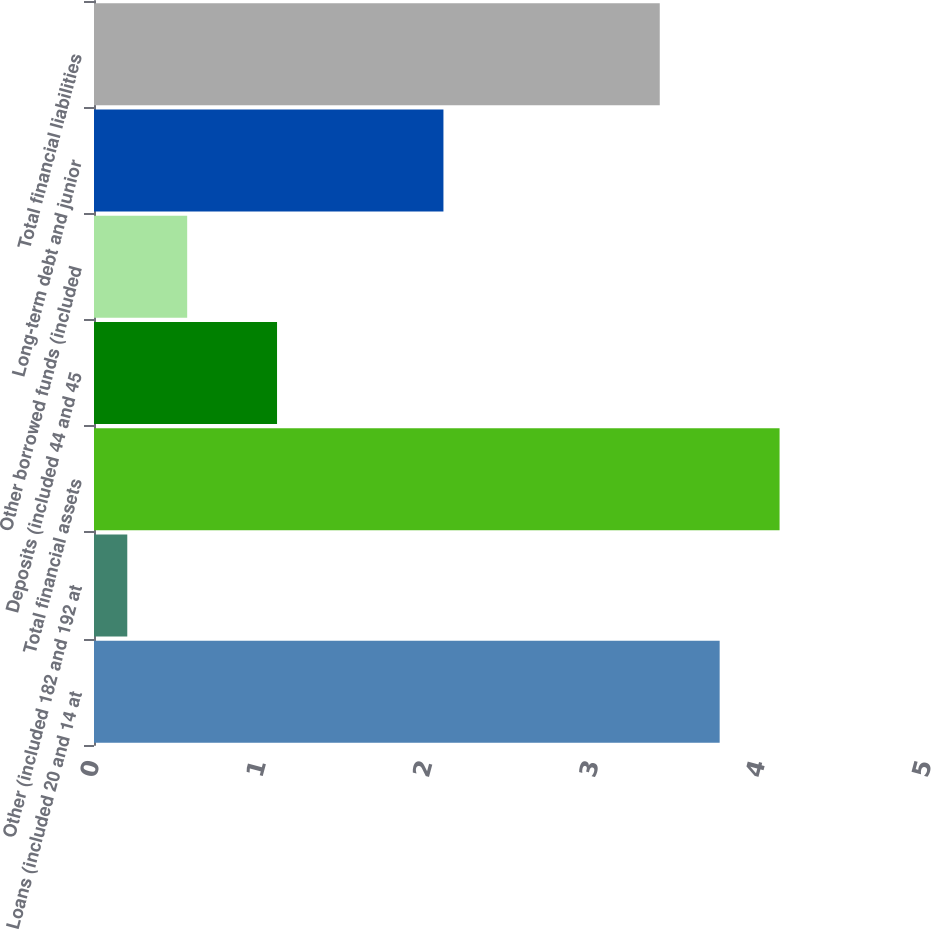<chart> <loc_0><loc_0><loc_500><loc_500><bar_chart><fcel>Loans (included 20 and 14 at<fcel>Other (included 182 and 192 at<fcel>Total financial assets<fcel>Deposits (included 44 and 45<fcel>Other borrowed funds (included<fcel>Long-term debt and junior<fcel>Total financial liabilities<nl><fcel>3.76<fcel>0.2<fcel>4.12<fcel>1.1<fcel>0.56<fcel>2.1<fcel>3.4<nl></chart> 